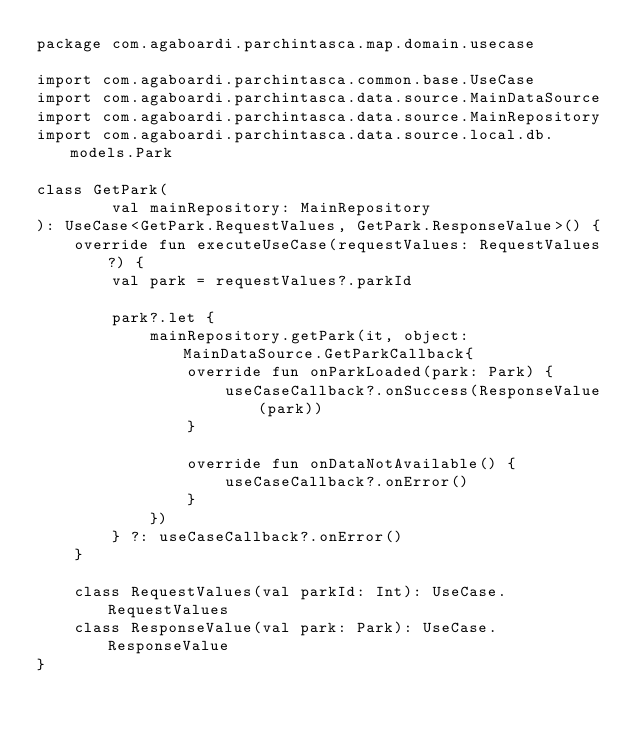<code> <loc_0><loc_0><loc_500><loc_500><_Kotlin_>package com.agaboardi.parchintasca.map.domain.usecase

import com.agaboardi.parchintasca.common.base.UseCase
import com.agaboardi.parchintasca.data.source.MainDataSource
import com.agaboardi.parchintasca.data.source.MainRepository
import com.agaboardi.parchintasca.data.source.local.db.models.Park

class GetPark(
        val mainRepository: MainRepository
): UseCase<GetPark.RequestValues, GetPark.ResponseValue>() {
    override fun executeUseCase(requestValues: RequestValues?) {
        val park = requestValues?.parkId

        park?.let {
            mainRepository.getPark(it, object: MainDataSource.GetParkCallback{
                override fun onParkLoaded(park: Park) {
                    useCaseCallback?.onSuccess(ResponseValue(park))
                }

                override fun onDataNotAvailable() {
                    useCaseCallback?.onError()
                }
            })
        } ?: useCaseCallback?.onError()
    }

    class RequestValues(val parkId: Int): UseCase.RequestValues
    class ResponseValue(val park: Park): UseCase.ResponseValue
}</code> 